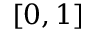<formula> <loc_0><loc_0><loc_500><loc_500>[ 0 , 1 ]</formula> 